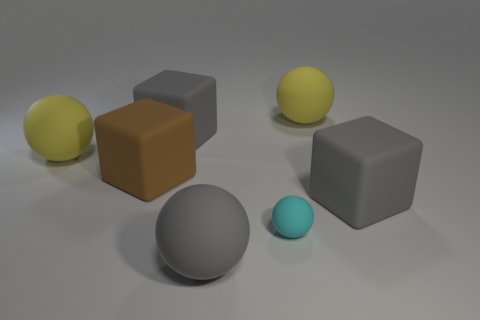Is the number of yellow matte balls that are in front of the cyan ball greater than the number of tiny objects?
Offer a very short reply. No. There is a gray rubber block on the left side of the gray matte block that is in front of the big brown rubber block; what number of big gray objects are on the right side of it?
Your answer should be very brief. 2. There is a yellow thing that is on the right side of the gray matte ball; does it have the same shape as the tiny cyan rubber object?
Keep it short and to the point. Yes. There is a sphere that is in front of the cyan object; what is it made of?
Provide a succinct answer. Rubber. There is a big gray rubber object that is on the left side of the cyan object and behind the tiny matte sphere; what shape is it?
Provide a succinct answer. Cube. What material is the brown object?
Keep it short and to the point. Rubber. What number of balls are tiny cyan matte objects or gray things?
Provide a short and direct response. 2. Are the big brown cube and the gray sphere made of the same material?
Keep it short and to the point. Yes. There is a gray matte thing that is the same shape as the cyan object; what size is it?
Offer a terse response. Large. What is the material of the big gray thing that is both left of the cyan thing and behind the cyan sphere?
Provide a short and direct response. Rubber. 